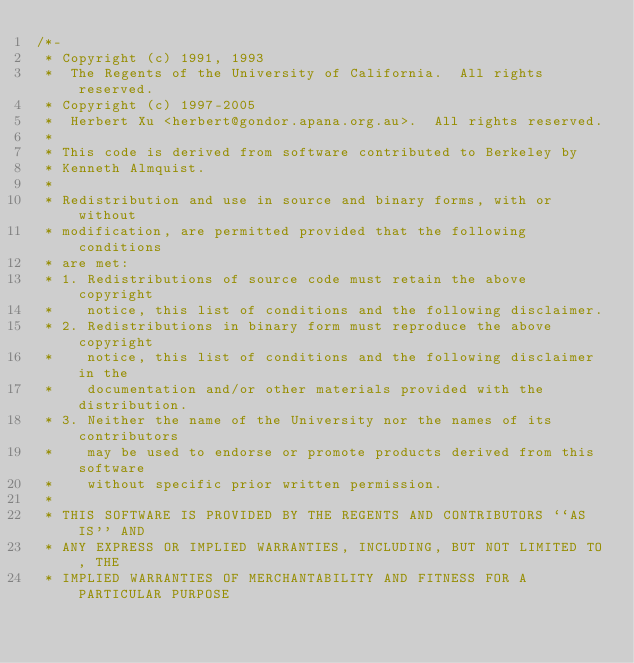<code> <loc_0><loc_0><loc_500><loc_500><_C_>/*-
 * Copyright (c) 1991, 1993
 *	The Regents of the University of California.  All rights reserved.
 * Copyright (c) 1997-2005
 *	Herbert Xu <herbert@gondor.apana.org.au>.  All rights reserved.
 *
 * This code is derived from software contributed to Berkeley by
 * Kenneth Almquist.
 *
 * Redistribution and use in source and binary forms, with or without
 * modification, are permitted provided that the following conditions
 * are met:
 * 1. Redistributions of source code must retain the above copyright
 *    notice, this list of conditions and the following disclaimer.
 * 2. Redistributions in binary form must reproduce the above copyright
 *    notice, this list of conditions and the following disclaimer in the
 *    documentation and/or other materials provided with the distribution.
 * 3. Neither the name of the University nor the names of its contributors
 *    may be used to endorse or promote products derived from this software
 *    without specific prior written permission.
 *
 * THIS SOFTWARE IS PROVIDED BY THE REGENTS AND CONTRIBUTORS ``AS IS'' AND
 * ANY EXPRESS OR IMPLIED WARRANTIES, INCLUDING, BUT NOT LIMITED TO, THE
 * IMPLIED WARRANTIES OF MERCHANTABILITY AND FITNESS FOR A PARTICULAR PURPOSE</code> 